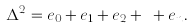Convert formula to latex. <formula><loc_0><loc_0><loc_500><loc_500>\Delta ^ { 2 } = e _ { 0 } + e _ { 1 } + e _ { 2 } + \dots + e _ { n } .</formula> 